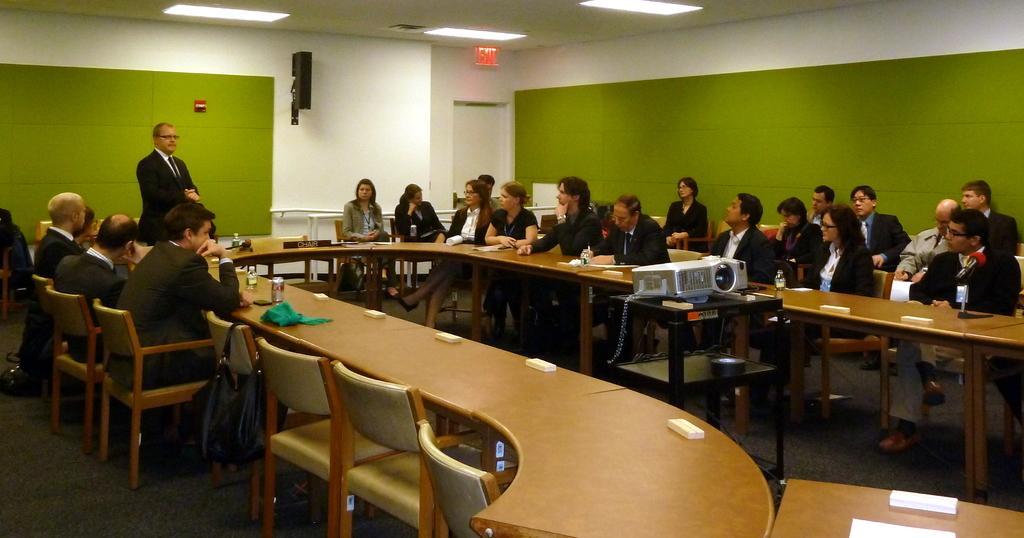In one or two sentences, can you explain what this image depicts? In this picture we can see some persons sitting on the chairs. This is the table. And these are some electronic devices on the table. Here we can see a man who is standing on the floor. He is in suit and he has spectacles. On the background there is a wall and these are the lights. 